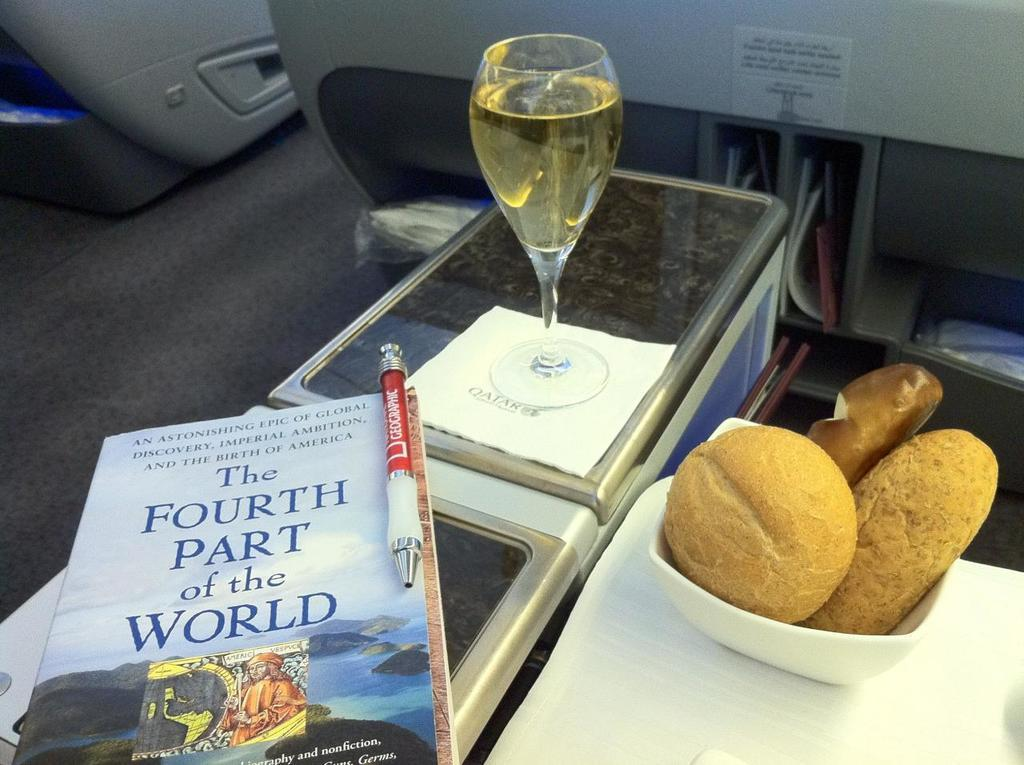<image>
Relay a brief, clear account of the picture shown. a book next to a wine glass titled 'the fourth part of the world' 